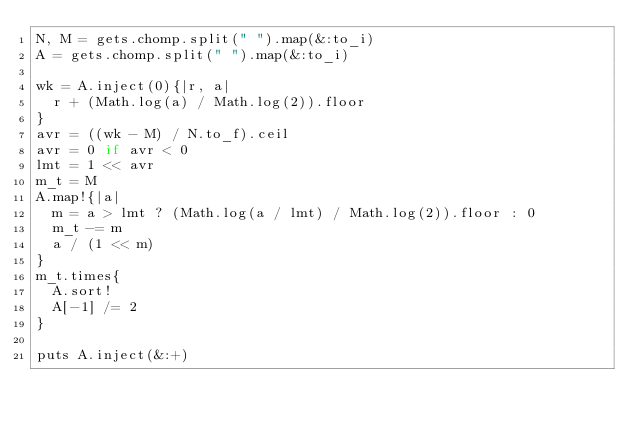Convert code to text. <code><loc_0><loc_0><loc_500><loc_500><_Ruby_>N, M = gets.chomp.split(" ").map(&:to_i)
A = gets.chomp.split(" ").map(&:to_i)

wk = A.inject(0){|r, a|
  r + (Math.log(a) / Math.log(2)).floor
}
avr = ((wk - M) / N.to_f).ceil
avr = 0 if avr < 0
lmt = 1 << avr
m_t = M
A.map!{|a|
  m = a > lmt ? (Math.log(a / lmt) / Math.log(2)).floor : 0
  m_t -= m
  a / (1 << m)
}
m_t.times{
  A.sort!
  A[-1] /= 2
}

puts A.inject(&:+)
</code> 